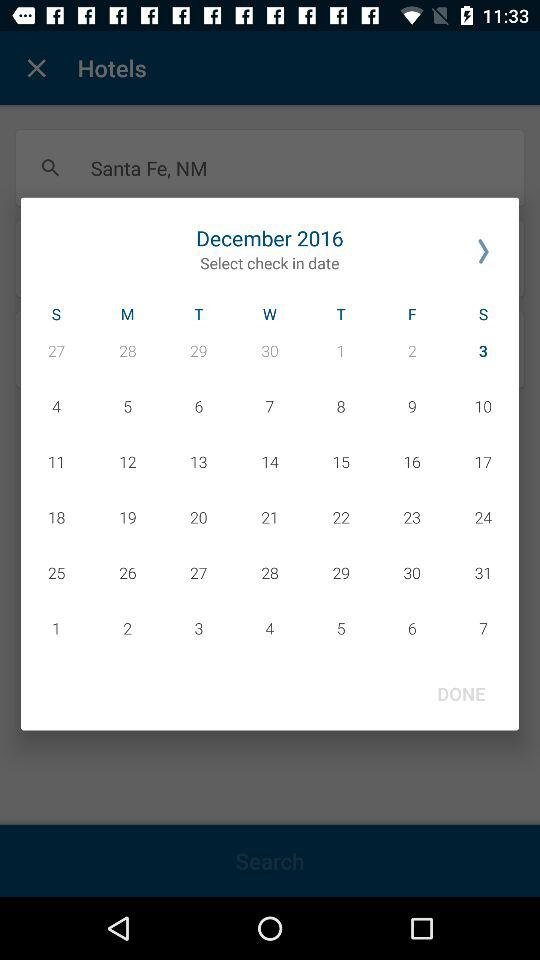What is the selected date? The selected date is Saturday, December 3, 2016. 